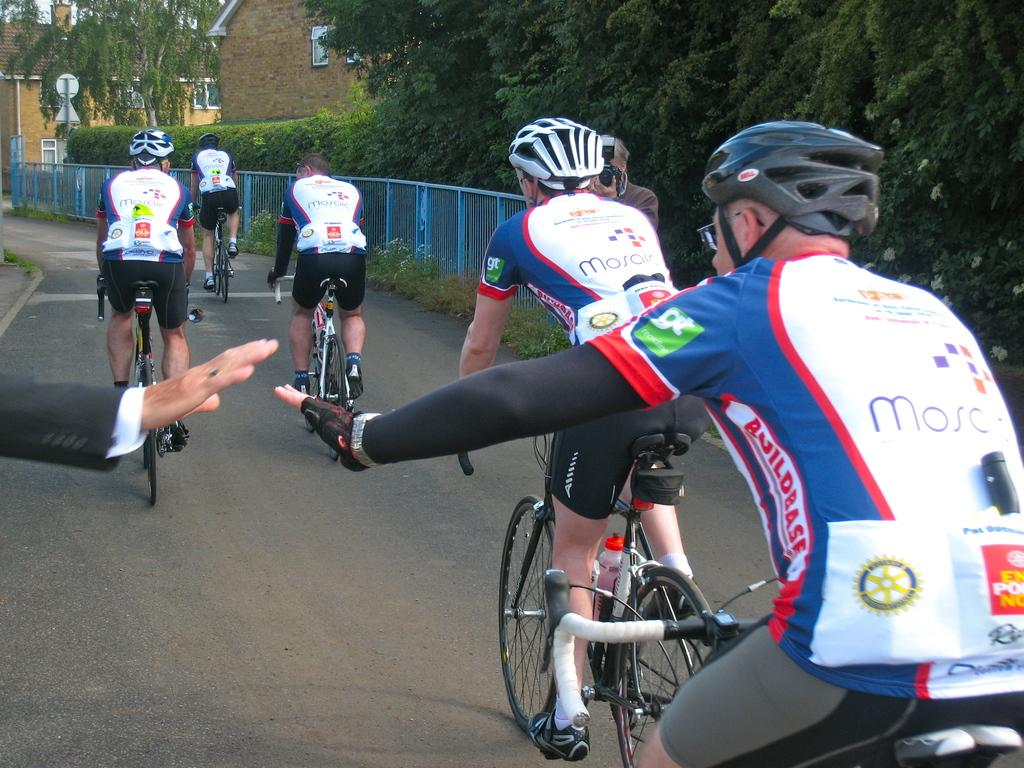What are the people in the image doing? The people in the image are riding bicycles. What can be seen in the background of the image? There are trees and buildings in the background of the image. Where is the giraffe hiding in the image? There is no giraffe present in the image. 